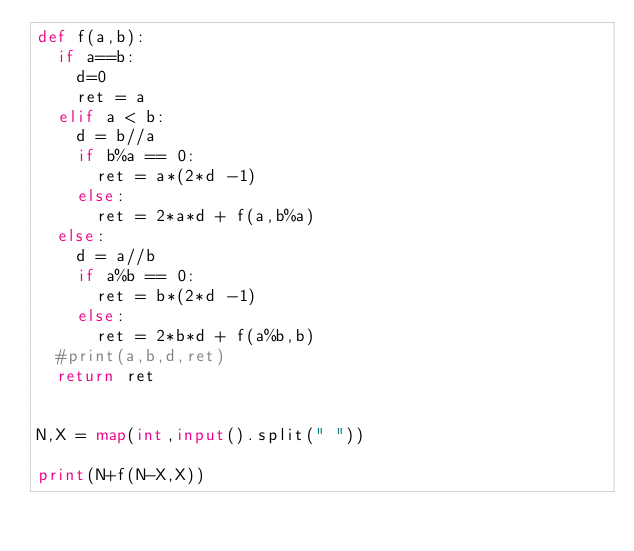<code> <loc_0><loc_0><loc_500><loc_500><_Python_>def f(a,b):
	if a==b:
		d=0
		ret = a
	elif a < b:
		d = b//a
		if b%a == 0:
			ret = a*(2*d -1)
		else:
			ret = 2*a*d + f(a,b%a)
	else:
		d = a//b
		if a%b == 0:
			ret = b*(2*d -1)
		else:
			ret = 2*b*d + f(a%b,b)
	#print(a,b,d,ret)
	return ret


N,X = map(int,input().split(" "))

print(N+f(N-X,X))</code> 